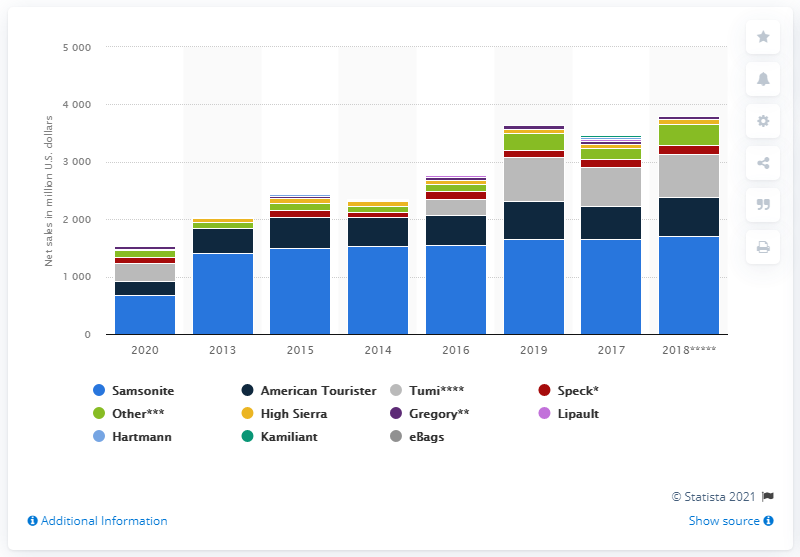Point out several critical features in this image. In 2020, the American Tourister brand generated $244.5 million in revenue for Samsonite. 